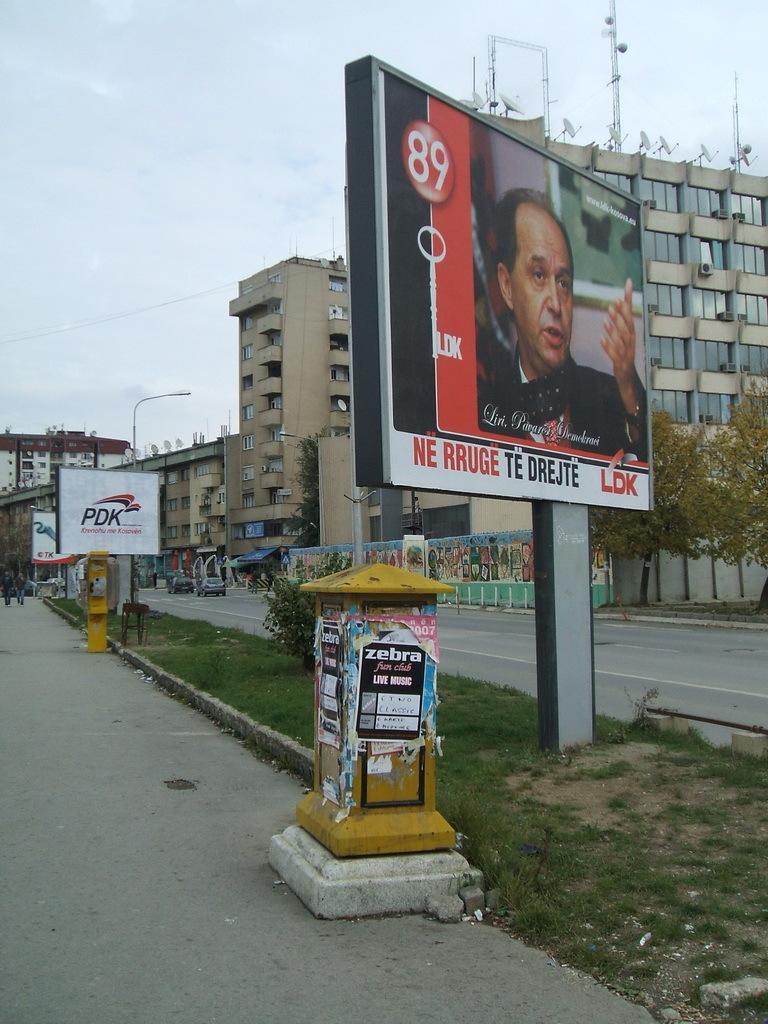What does the left ad say?
Provide a short and direct response. Pdk. What number is printed on the top left corner of the largest billboard?
Ensure brevity in your answer.  89. 